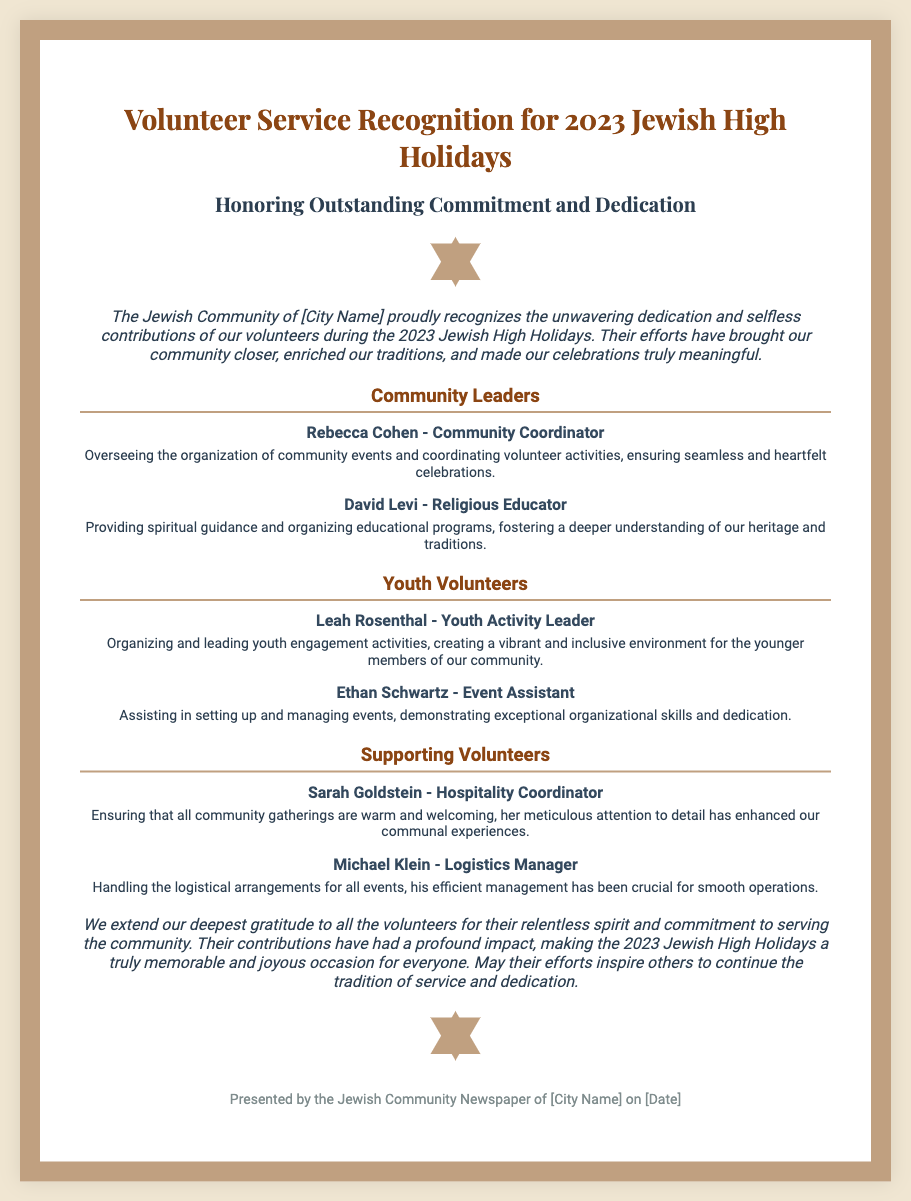what is the title of the diploma? The title of the diploma is mentioned at the top of the document and reflects its purpose.
Answer: Volunteer Service Recognition for 2023 Jewish High Holidays who is honored as the Community Coordinator? The document lists specific individuals and their roles, including the Community Coordinator.
Answer: Rebecca Cohen how many sections are there for volunteers? The number of sections is indicated in the layout of the document separate community contributions.
Answer: Three what role does Leah Rosenthal have? The document specifies the roles of various volunteers, including Leah Rosenthal.
Answer: Youth Activity Leader what is the significance of the volunteers' contributions during the holidays? The introduction and closing sections highlight the overarching impact and significance of the volunteers' service.
Answer: Enriched our traditions who coordinated hospitality? The document identifies the individuals responsible for specific support roles within the community.
Answer: Sarah Goldstein which date is mentioned in the footer? The footer typically contains pertinent details, including when the diploma is presented.
Answer: [Date] what is the color of the diploma's border? The style section describes the visual features of the diploma, including the border color.
Answer: #c0a080 